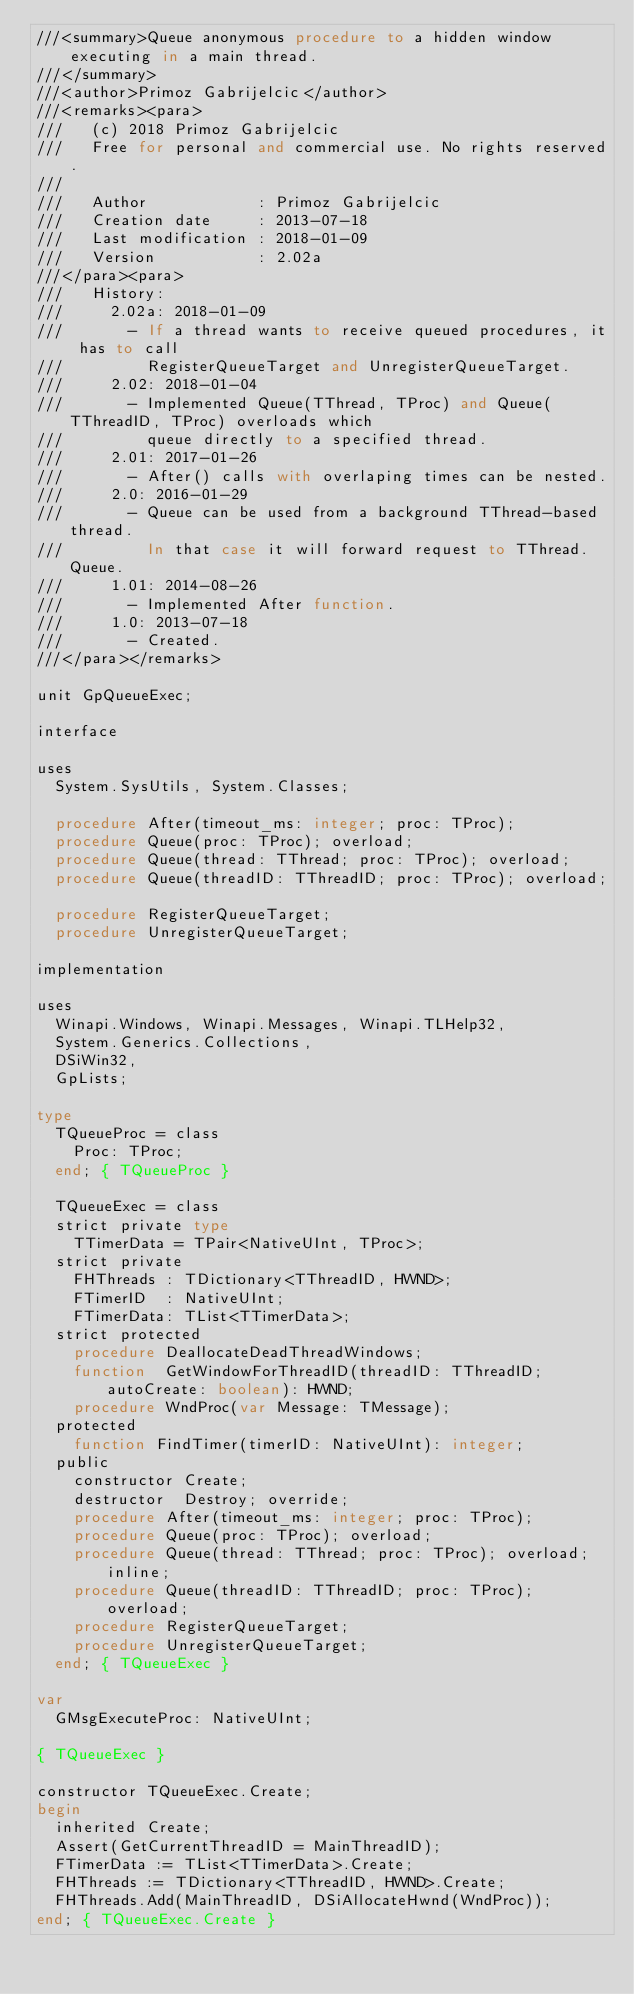<code> <loc_0><loc_0><loc_500><loc_500><_Pascal_>///<summary>Queue anonymous procedure to a hidden window executing in a main thread.
///</summary>
///<author>Primoz Gabrijelcic</author>
///<remarks><para>
///   (c) 2018 Primoz Gabrijelcic
///   Free for personal and commercial use. No rights reserved.
///
///   Author            : Primoz Gabrijelcic
///   Creation date     : 2013-07-18
///   Last modification : 2018-01-09
///   Version           : 2.02a
///</para><para>
///   History:
///     2.02a: 2018-01-09
///       - If a thread wants to receive queued procedures, it has to call
///         RegisterQueueTarget and UnregisterQueueTarget.
///     2.02: 2018-01-04
///       - Implemented Queue(TThread, TProc) and Queue(TThreadID, TProc) overloads which
///         queue directly to a specified thread.
///     2.01: 2017-01-26
///       - After() calls with overlaping times can be nested.
///     2.0: 2016-01-29
///       - Queue can be used from a background TThread-based thread.
///         In that case it will forward request to TThread.Queue.
///     1.01: 2014-08-26
///       - Implemented After function.
///     1.0: 2013-07-18
///       - Created.
///</para></remarks>

unit GpQueueExec;

interface

uses
  System.SysUtils, System.Classes;

  procedure After(timeout_ms: integer; proc: TProc);
  procedure Queue(proc: TProc); overload;
  procedure Queue(thread: TThread; proc: TProc); overload;
  procedure Queue(threadID: TThreadID; proc: TProc); overload;

  procedure RegisterQueueTarget;
  procedure UnregisterQueueTarget;

implementation

uses
  Winapi.Windows, Winapi.Messages, Winapi.TLHelp32,
  System.Generics.Collections,
  DSiWin32,
  GpLists;

type
  TQueueProc = class
    Proc: TProc;
  end; { TQueueProc }

  TQueueExec = class
  strict private type
    TTimerData = TPair<NativeUInt, TProc>;
  strict private
    FHThreads : TDictionary<TThreadID, HWND>;
    FTimerID  : NativeUInt;
    FTimerData: TList<TTimerData>;
  strict protected
    procedure DeallocateDeadThreadWindows;
    function  GetWindowForThreadID(threadID: TThreadID; autoCreate: boolean): HWND;
    procedure WndProc(var Message: TMessage);
  protected
    function FindTimer(timerID: NativeUInt): integer;
  public
    constructor Create;
    destructor  Destroy; override;
    procedure After(timeout_ms: integer; proc: TProc);
    procedure Queue(proc: TProc); overload;
    procedure Queue(thread: TThread; proc: TProc); overload; inline;
    procedure Queue(threadID: TThreadID; proc: TProc); overload;
    procedure RegisterQueueTarget;
    procedure UnregisterQueueTarget;
  end; { TQueueExec }

var
  GMsgExecuteProc: NativeUInt;

{ TQueueExec }

constructor TQueueExec.Create;
begin
  inherited Create;
  Assert(GetCurrentThreadID = MainThreadID);
  FTimerData := TList<TTimerData>.Create;
  FHThreads := TDictionary<TThreadID, HWND>.Create;
  FHThreads.Add(MainThreadID, DSiAllocateHwnd(WndProc));
end; { TQueueExec.Create }
</code> 